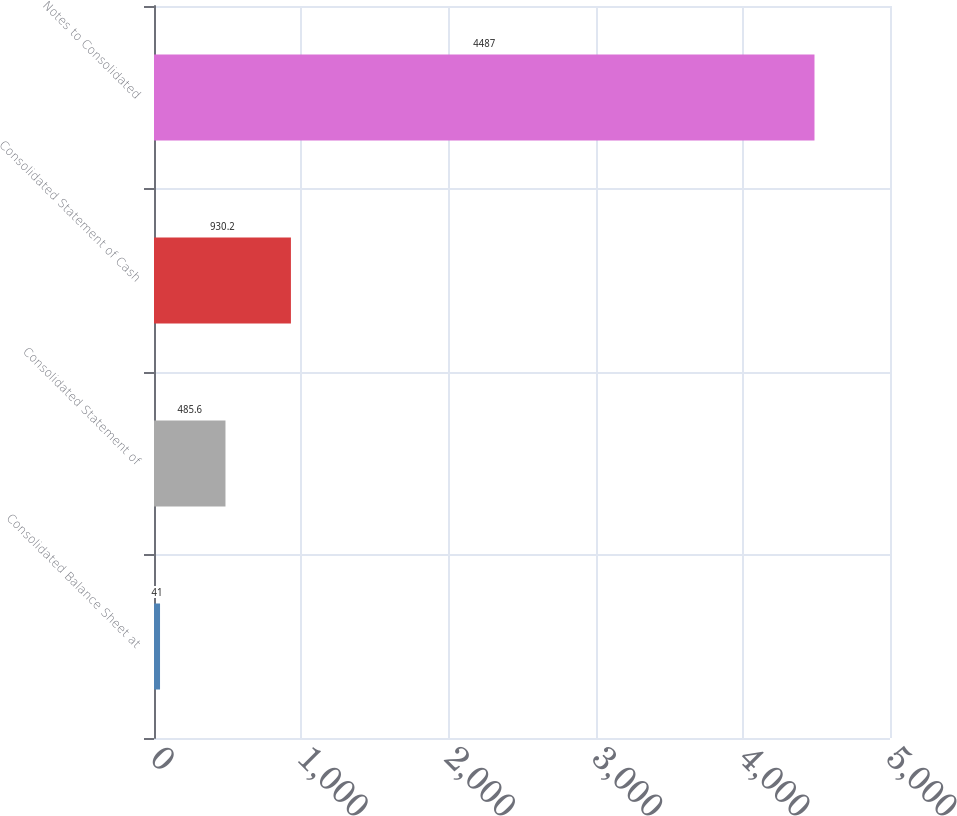Convert chart to OTSL. <chart><loc_0><loc_0><loc_500><loc_500><bar_chart><fcel>Consolidated Balance Sheet at<fcel>Consolidated Statement of<fcel>Consolidated Statement of Cash<fcel>Notes to Consolidated<nl><fcel>41<fcel>485.6<fcel>930.2<fcel>4487<nl></chart> 